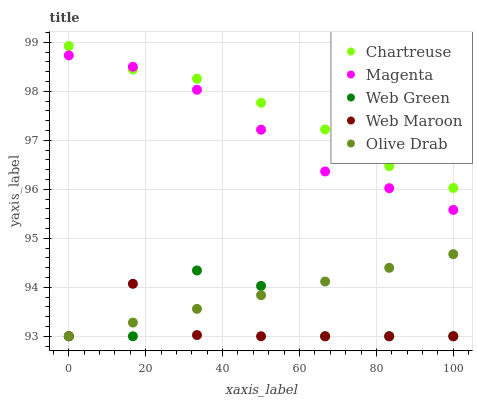Does Web Maroon have the minimum area under the curve?
Answer yes or no. Yes. Does Chartreuse have the maximum area under the curve?
Answer yes or no. Yes. Does Chartreuse have the minimum area under the curve?
Answer yes or no. No. Does Web Maroon have the maximum area under the curve?
Answer yes or no. No. Is Olive Drab the smoothest?
Answer yes or no. Yes. Is Web Green the roughest?
Answer yes or no. Yes. Is Chartreuse the smoothest?
Answer yes or no. No. Is Chartreuse the roughest?
Answer yes or no. No. Does Olive Drab have the lowest value?
Answer yes or no. Yes. Does Chartreuse have the lowest value?
Answer yes or no. No. Does Chartreuse have the highest value?
Answer yes or no. Yes. Does Web Maroon have the highest value?
Answer yes or no. No. Is Web Green less than Magenta?
Answer yes or no. Yes. Is Chartreuse greater than Web Green?
Answer yes or no. Yes. Does Web Green intersect Olive Drab?
Answer yes or no. Yes. Is Web Green less than Olive Drab?
Answer yes or no. No. Is Web Green greater than Olive Drab?
Answer yes or no. No. Does Web Green intersect Magenta?
Answer yes or no. No. 